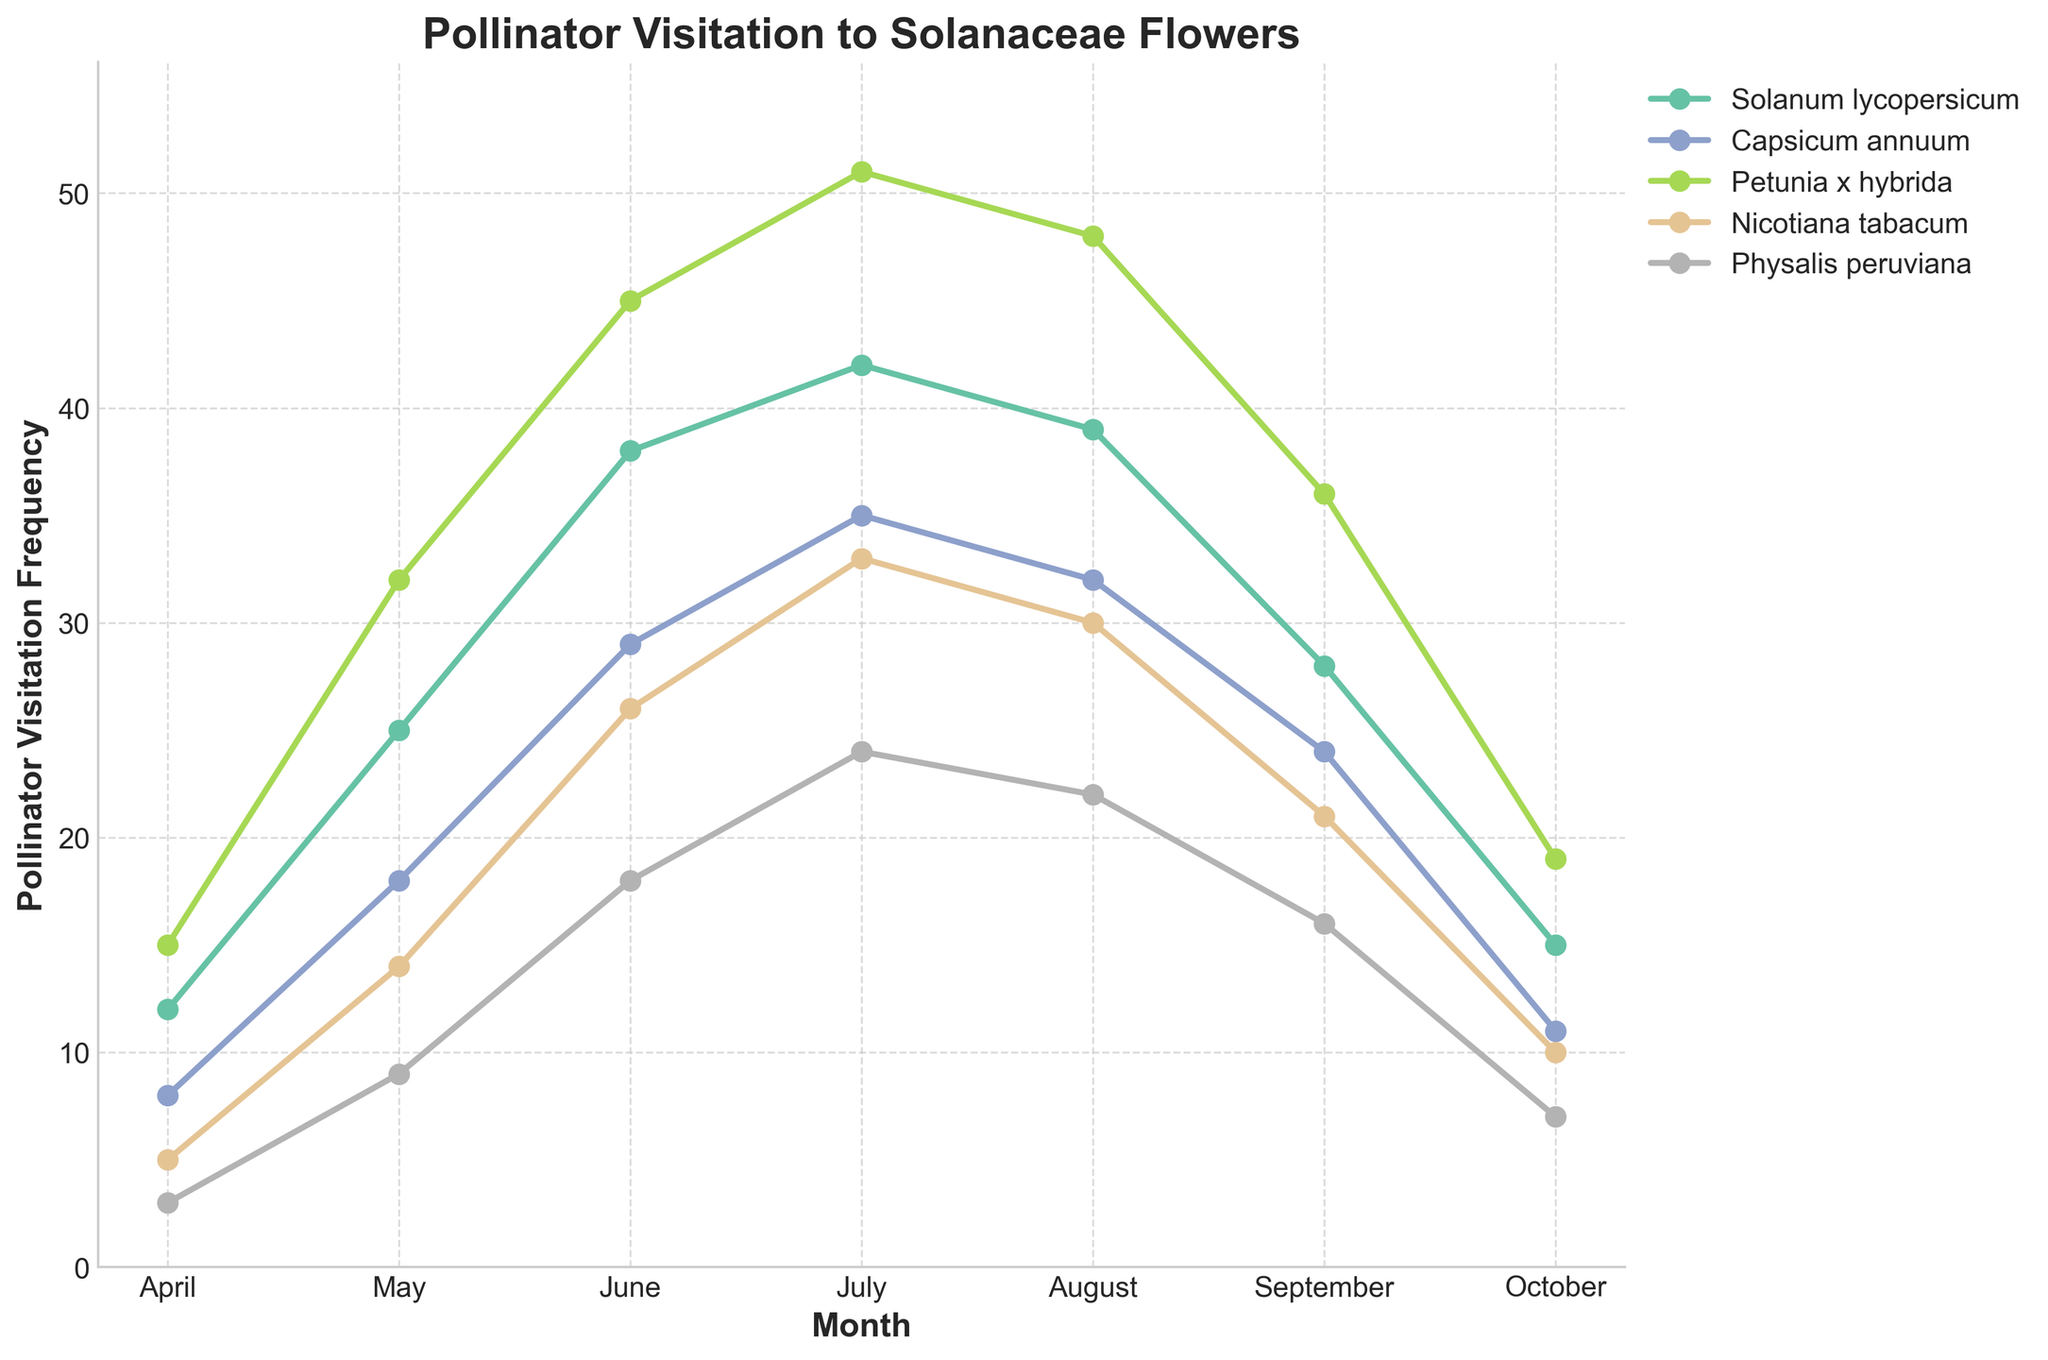What is the peak pollinator visitation frequency for Petunia x hybrida? By examining the line chart, find the point where the line representing Petunia x hybrida reaches its highest y-value. This highest point occurs in July.
Answer: 51 Which species had the lowest visitation in October? Look at the October values for all species in the figure and determine the smallest number. Physalis peruviana has the lowest visitation frequency in October.
Answer: Physalis peruviana How does the visitation frequency for Nicotiana tabacum in July compare to that in April? Compare the two points on the Nicotiana tabacum line. In July, the frequency is 33, and in April, it is 5.
Answer: July is higher by 28 What is the average pollinator visitation frequency for Capsicum annuum across the months? Sum the values for Capsicum annuum (8 + 18 + 29 + 35 + 32 + 24 + 11 = 157) and divide by the number of values (157/7).
Answer: 22.43 Which month sees the greatest increase in visitation for Solanum lycopersicum from the previous month? Examine month-to-month changes for Solanum lycopersicum. The largest increase occurs between April and May (25 - 12 = 13).
Answer: May What is the difference in visitation frequency between Physalis peruviana and Solanum lycopersicum in June? Look at the y-values for both species in June. Solanum lycopersicum is 38 and Physalis peruviana is 18, so the difference is (38 - 18).
Answer: 20 During which month do all species experience a decrease in visitation frequency compared to the previous month? Observe each species' trends month-by-month. All lines show a decreasing trend from August to September.
Answer: September What is the cumulative total of pollinator visitation for all species in May? Add the visitation frequencies for all species in May (25 + 18 + 32 + 14 + 9 = 98).
Answer: 98 In which month does Petunia x hybrida have a visitation frequency closest to the average monthly visitation frequency across all months? Calculate the average visitation for Petunia x hybrida (153 / 7 ≈ 21.86) and look for the month where the visitation is closest to this average. June, with a visit frequency of 45, is notably above average. October, with a frequency of 19, is the closest.
Answer: October 